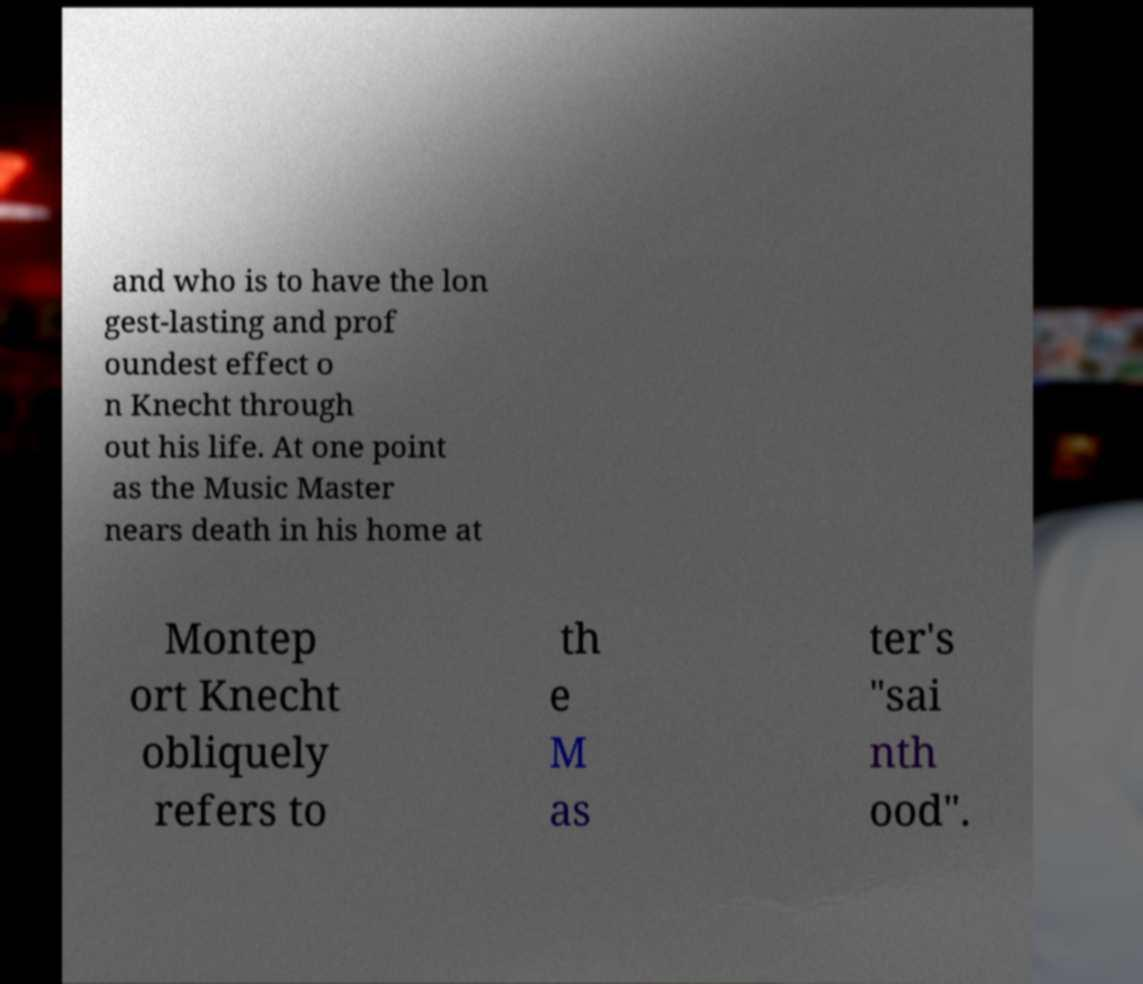Could you extract and type out the text from this image? and who is to have the lon gest-lasting and prof oundest effect o n Knecht through out his life. At one point as the Music Master nears death in his home at Montep ort Knecht obliquely refers to th e M as ter's "sai nth ood". 